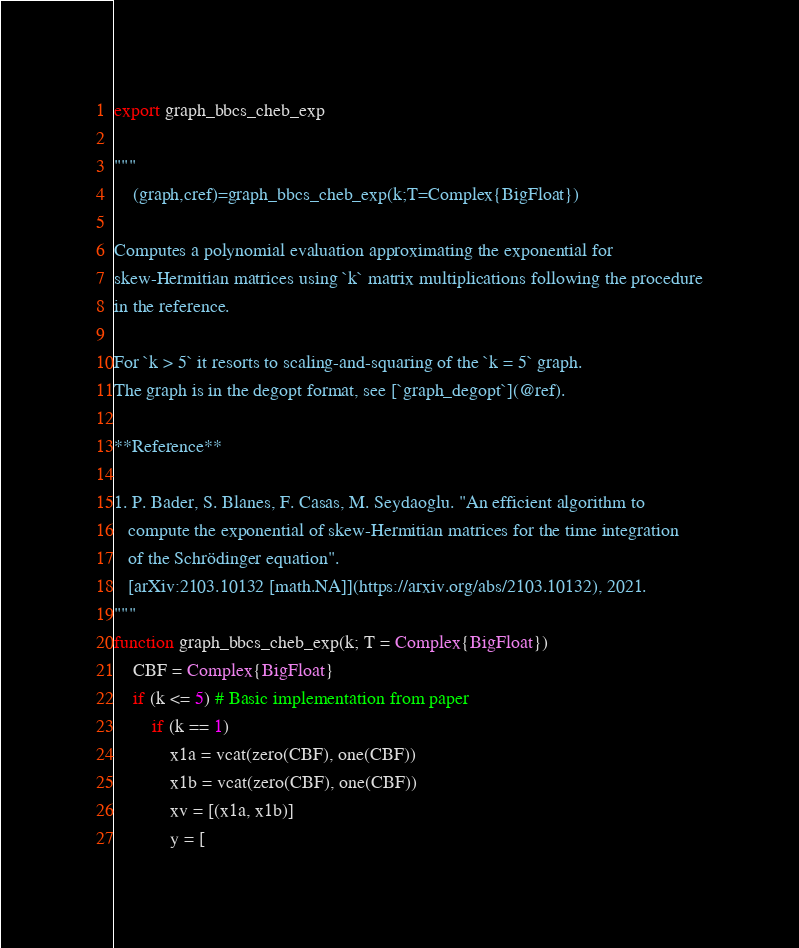Convert code to text. <code><loc_0><loc_0><loc_500><loc_500><_Julia_>export graph_bbcs_cheb_exp

"""
    (graph,cref)=graph_bbcs_cheb_exp(k;T=Complex{BigFloat})

Computes a polynomial evaluation approximating the exponential for
skew-Hermitian matrices using `k` matrix multiplications following the procedure
in the reference.

For `k > 5` it resorts to scaling-and-squaring of the `k = 5` graph.
The graph is in the degopt format, see [`graph_degopt`](@ref).

**Reference**

1. P. Bader, S. Blanes, F. Casas, M. Seydaoglu. "An efficient algorithm to
   compute the exponential of skew-Hermitian matrices for the time integration
   of the Schrödinger equation".
   [arXiv:2103.10132 [math.NA]](https://arxiv.org/abs/2103.10132), 2021.
"""
function graph_bbcs_cheb_exp(k; T = Complex{BigFloat})
    CBF = Complex{BigFloat}
    if (k <= 5) # Basic implementation from paper
        if (k == 1)
            x1a = vcat(zero(CBF), one(CBF))
            x1b = vcat(zero(CBF), one(CBF))
            xv = [(x1a, x1b)]
            y = [</code> 